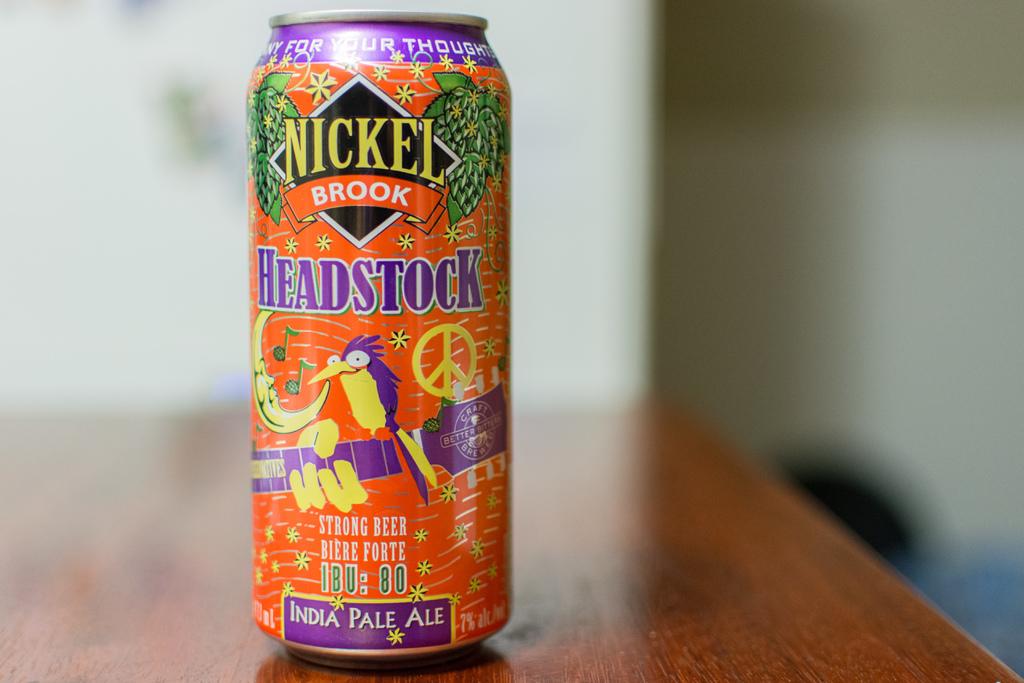What kind of beer is this?
Provide a succinct answer. India pale ale. Is that alcoholic?
Your response must be concise. Yes. 